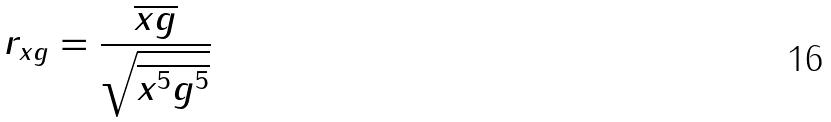<formula> <loc_0><loc_0><loc_500><loc_500>r _ { x g } = \frac { \overline { x g } } { \sqrt { \overline { x ^ { 5 } } \overline { g ^ { 5 } } } }</formula> 